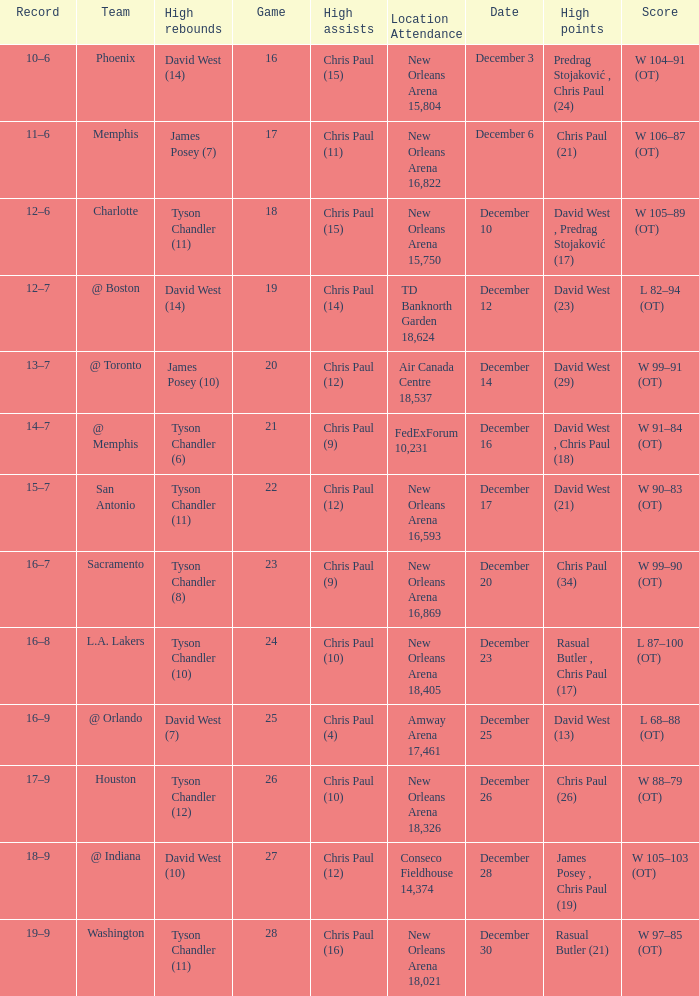Help me parse the entirety of this table. {'header': ['Record', 'Team', 'High rebounds', 'Game', 'High assists', 'Location Attendance', 'Date', 'High points', 'Score'], 'rows': [['10–6', 'Phoenix', 'David West (14)', '16', 'Chris Paul (15)', 'New Orleans Arena 15,804', 'December 3', 'Predrag Stojaković , Chris Paul (24)', 'W 104–91 (OT)'], ['11–6', 'Memphis', 'James Posey (7)', '17', 'Chris Paul (11)', 'New Orleans Arena 16,822', 'December 6', 'Chris Paul (21)', 'W 106–87 (OT)'], ['12–6', 'Charlotte', 'Tyson Chandler (11)', '18', 'Chris Paul (15)', 'New Orleans Arena 15,750', 'December 10', 'David West , Predrag Stojaković (17)', 'W 105–89 (OT)'], ['12–7', '@ Boston', 'David West (14)', '19', 'Chris Paul (14)', 'TD Banknorth Garden 18,624', 'December 12', 'David West (23)', 'L 82–94 (OT)'], ['13–7', '@ Toronto', 'James Posey (10)', '20', 'Chris Paul (12)', 'Air Canada Centre 18,537', 'December 14', 'David West (29)', 'W 99–91 (OT)'], ['14–7', '@ Memphis', 'Tyson Chandler (6)', '21', 'Chris Paul (9)', 'FedExForum 10,231', 'December 16', 'David West , Chris Paul (18)', 'W 91–84 (OT)'], ['15–7', 'San Antonio', 'Tyson Chandler (11)', '22', 'Chris Paul (12)', 'New Orleans Arena 16,593', 'December 17', 'David West (21)', 'W 90–83 (OT)'], ['16–7', 'Sacramento', 'Tyson Chandler (8)', '23', 'Chris Paul (9)', 'New Orleans Arena 16,869', 'December 20', 'Chris Paul (34)', 'W 99–90 (OT)'], ['16–8', 'L.A. Lakers', 'Tyson Chandler (10)', '24', 'Chris Paul (10)', 'New Orleans Arena 18,405', 'December 23', 'Rasual Butler , Chris Paul (17)', 'L 87–100 (OT)'], ['16–9', '@ Orlando', 'David West (7)', '25', 'Chris Paul (4)', 'Amway Arena 17,461', 'December 25', 'David West (13)', 'L 68–88 (OT)'], ['17–9', 'Houston', 'Tyson Chandler (12)', '26', 'Chris Paul (10)', 'New Orleans Arena 18,326', 'December 26', 'Chris Paul (26)', 'W 88–79 (OT)'], ['18–9', '@ Indiana', 'David West (10)', '27', 'Chris Paul (12)', 'Conseco Fieldhouse 14,374', 'December 28', 'James Posey , Chris Paul (19)', 'W 105–103 (OT)'], ['19–9', 'Washington', 'Tyson Chandler (11)', '28', 'Chris Paul (16)', 'New Orleans Arena 18,021', 'December 30', 'Rasual Butler (21)', 'W 97–85 (OT)']]} What is Score, when Team is "@ Memphis"? W 91–84 (OT). 